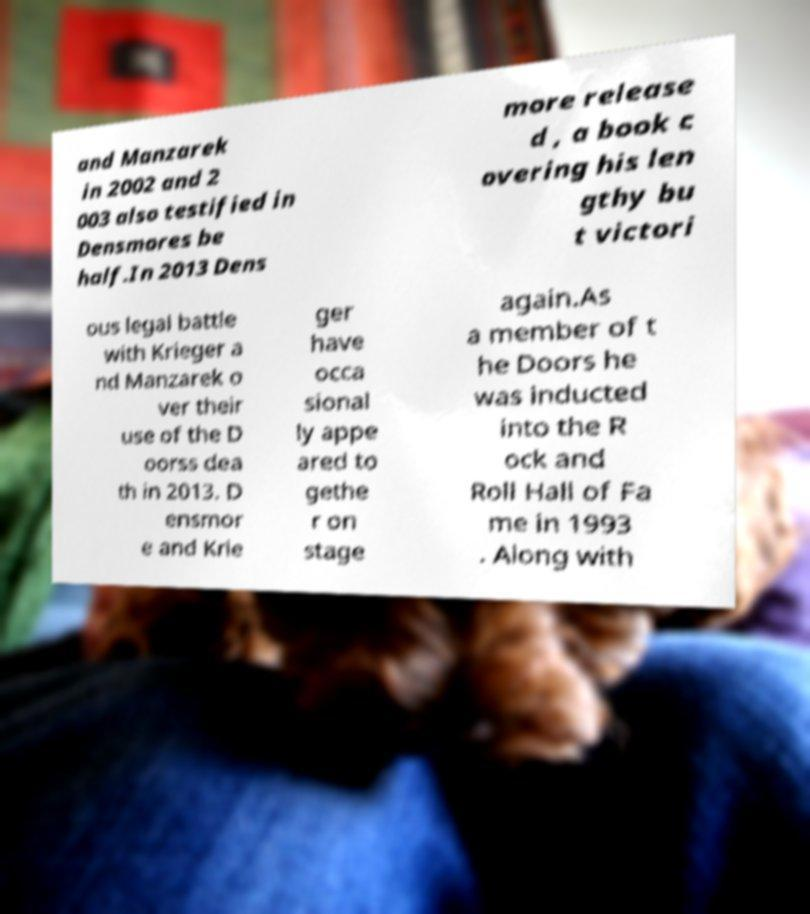Can you read and provide the text displayed in the image?This photo seems to have some interesting text. Can you extract and type it out for me? and Manzarek in 2002 and 2 003 also testified in Densmores be half.In 2013 Dens more release d , a book c overing his len gthy bu t victori ous legal battle with Krieger a nd Manzarek o ver their use of the D oorss dea th in 2013. D ensmor e and Krie ger have occa sional ly appe ared to gethe r on stage again.As a member of t he Doors he was inducted into the R ock and Roll Hall of Fa me in 1993 . Along with 